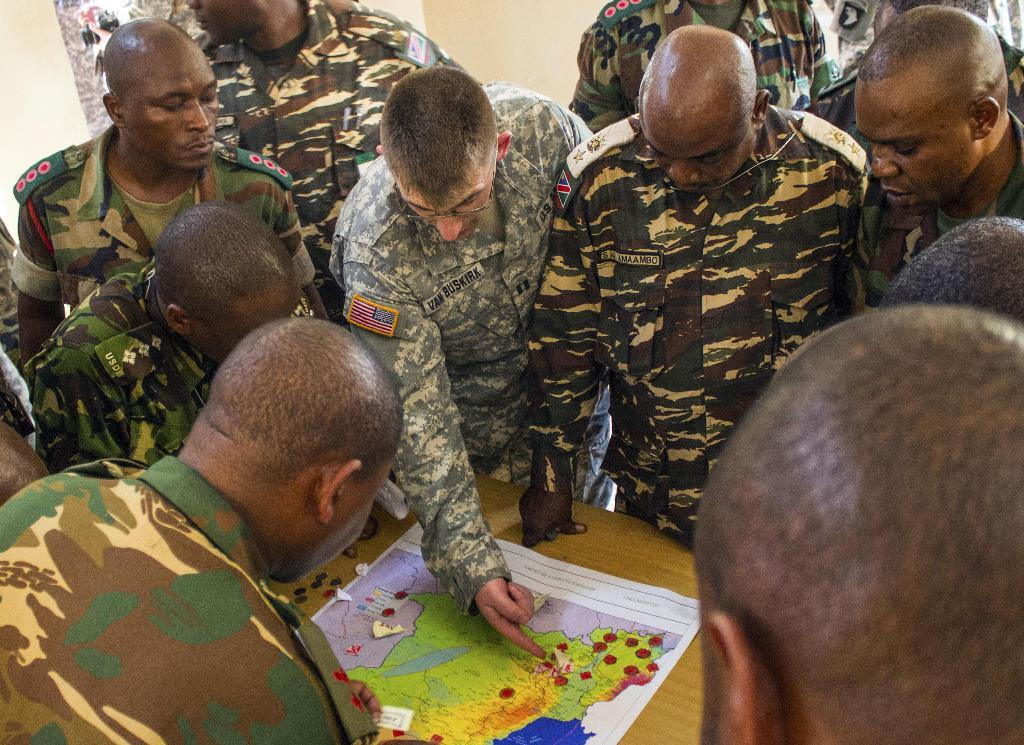What type of people are in the image? There are soldiers in the image. What are the soldiers doing in the image? The soldiers are discussing in the image. What can be seen in the center of the image? There is a desk in the center of the image. What items are on the desk? Coins and a map are present on the desk. What is visible in the background of the image? There is a wall in the image. What type of potato is being stored in the jar on the desk? There is no jar or potato present on the desk in the image. How many bridges can be seen connecting the soldiers in the image? There are no bridges visible in the image; it features soldiers discussing near a desk with coins and a map. 